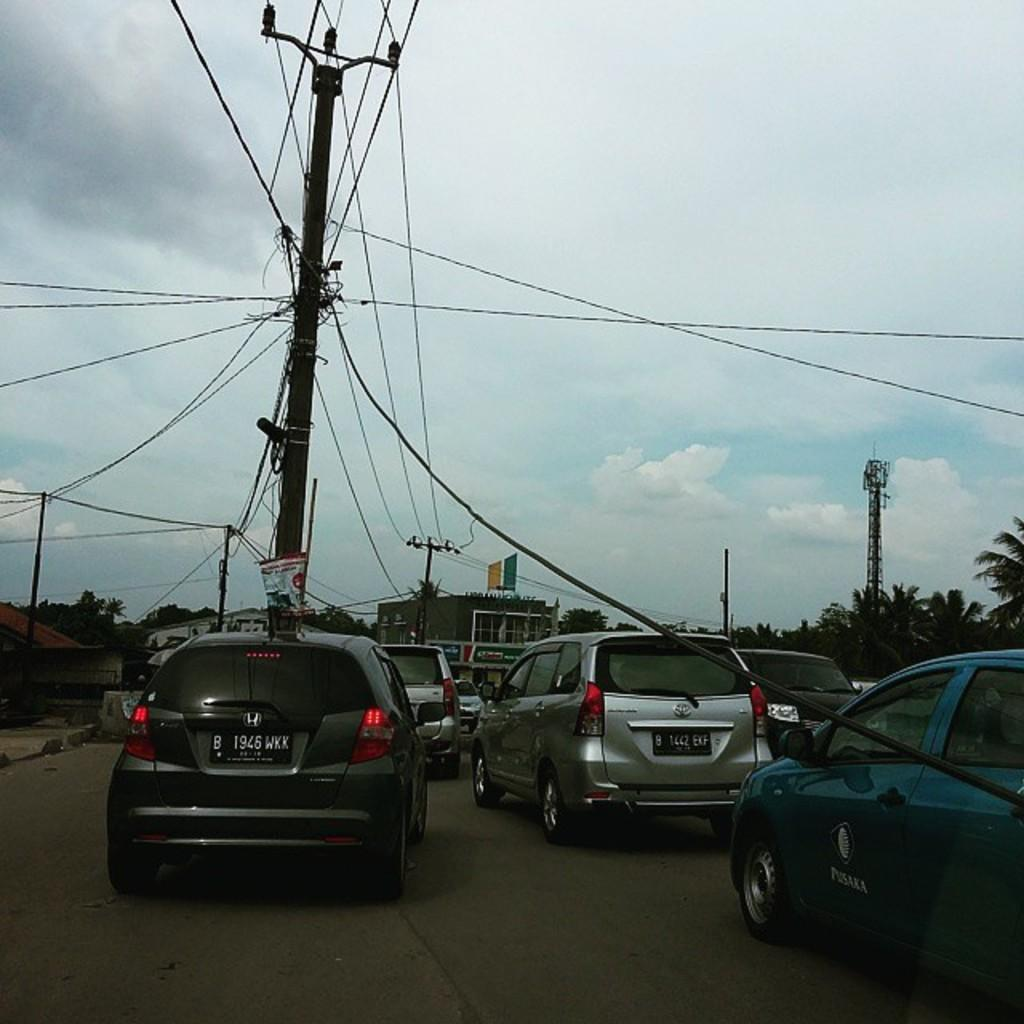What types of man-made structures can be seen in the image? There are vehicles, buildings, electric poles, and boards visible in the image. What natural elements are present in the image? There are trees in the image. What type of infrastructure can be seen in the image? There are cables in the image. What is visible in the background of the image? The sky is visible in the background of the image. Can you see any goldfish swimming in the image? There are no goldfish present in the image. Is there a volcano visible in the image? There is no volcano present in the image. 